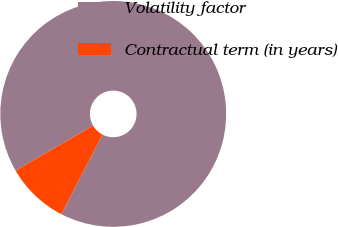Convert chart. <chart><loc_0><loc_0><loc_500><loc_500><pie_chart><fcel>Volatility factor<fcel>Contractual term (in years)<nl><fcel>90.99%<fcel>9.01%<nl></chart> 